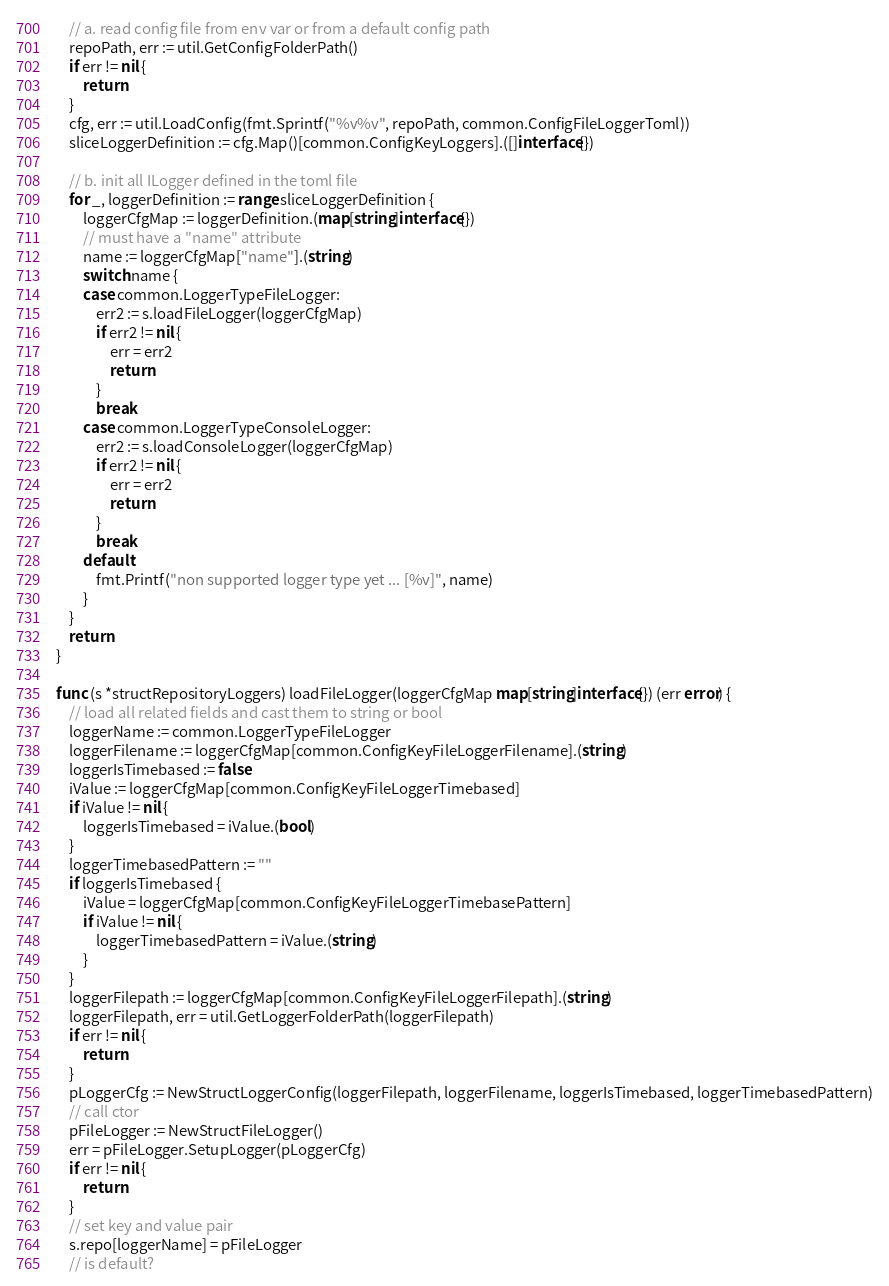<code> <loc_0><loc_0><loc_500><loc_500><_Go_>
	// a. read config file from env var or from a default config path
	repoPath, err := util.GetConfigFolderPath()
	if err != nil {
		return
	}
	cfg, err := util.LoadConfig(fmt.Sprintf("%v%v", repoPath, common.ConfigFileLoggerToml))
	sliceLoggerDefinition := cfg.Map()[common.ConfigKeyLoggers].([]interface{})

	// b. init all ILogger defined in the toml file
	for _, loggerDefinition := range sliceLoggerDefinition {
		loggerCfgMap := loggerDefinition.(map[string]interface{})
		// must have a "name" attribute
		name := loggerCfgMap["name"].(string)
		switch name {
		case common.LoggerTypeFileLogger:
			err2 := s.loadFileLogger(loggerCfgMap)
			if err2 != nil {
				err = err2
				return
			}
			break
		case common.LoggerTypeConsoleLogger:
			err2 := s.loadConsoleLogger(loggerCfgMap)
			if err2 != nil {
				err = err2
				return
			}
			break
		default:
			fmt.Printf("non supported logger type yet ... [%v]", name)
		}
	}
	return
}

func (s *structRepositoryLoggers) loadFileLogger(loggerCfgMap map[string]interface{}) (err error) {
	// load all related fields and cast them to string or bool
	loggerName := common.LoggerTypeFileLogger
	loggerFilename := loggerCfgMap[common.ConfigKeyFileLoggerFilename].(string)
	loggerIsTimebased := false
	iValue := loggerCfgMap[common.ConfigKeyFileLoggerTimebased]
	if iValue != nil {
		loggerIsTimebased = iValue.(bool)
	}
	loggerTimebasedPattern := ""
	if loggerIsTimebased {
		iValue = loggerCfgMap[common.ConfigKeyFileLoggerTimebasePattern]
		if iValue != nil {
			loggerTimebasedPattern = iValue.(string)
		}
	}
	loggerFilepath := loggerCfgMap[common.ConfigKeyFileLoggerFilepath].(string)
	loggerFilepath, err = util.GetLoggerFolderPath(loggerFilepath)
	if err != nil {
		return
	}
	pLoggerCfg := NewStructLoggerConfig(loggerFilepath, loggerFilename, loggerIsTimebased, loggerTimebasedPattern)
	// call ctor
	pFileLogger := NewStructFileLogger()
	err = pFileLogger.SetupLogger(pLoggerCfg)
	if err != nil {
		return
	}
	// set key and value pair
	s.repo[loggerName] = pFileLogger
	// is default?</code> 